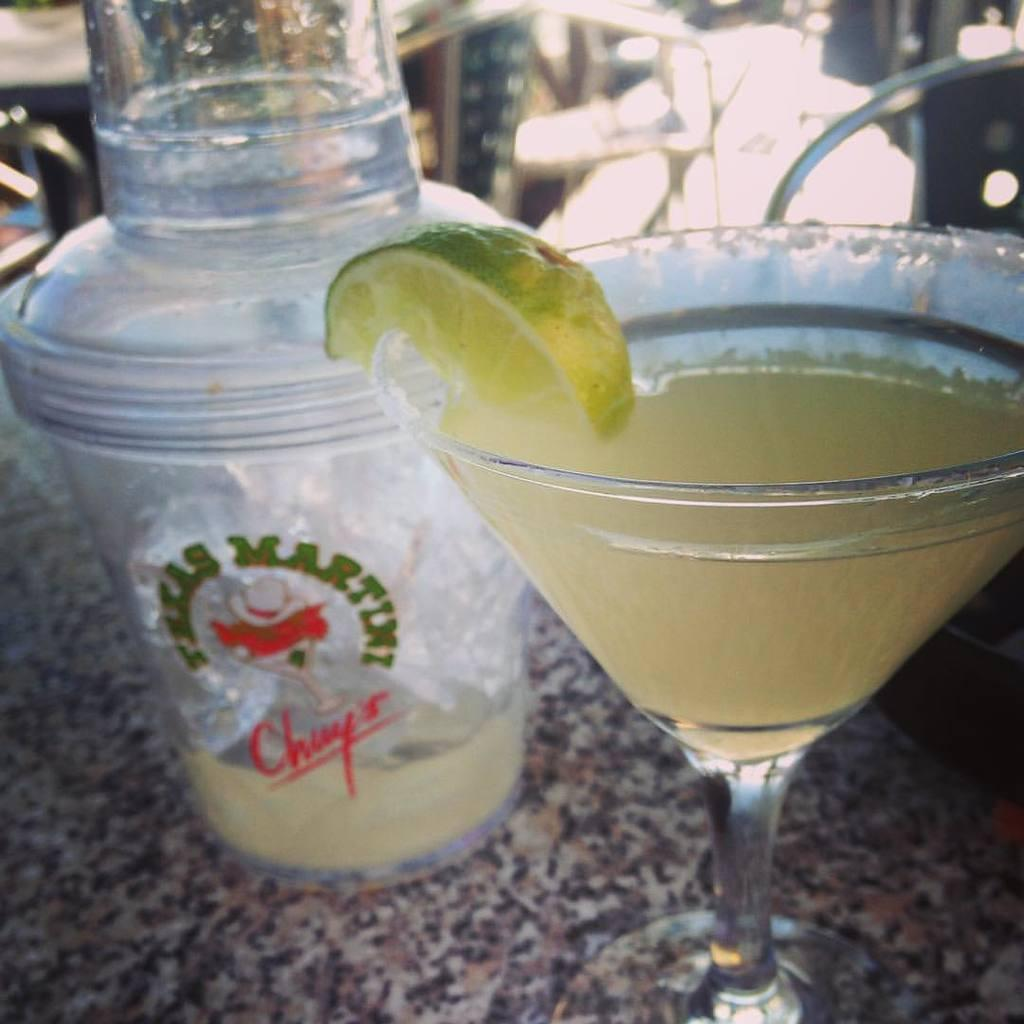What is one object visible in the image? There is a bottle in the image. What is another object visible in the image? There is a glass in the image. What is inside the glass? The glass contains a drink. How many stars can be seen kissing in the image? There are no stars or kissing actions present in the image. 